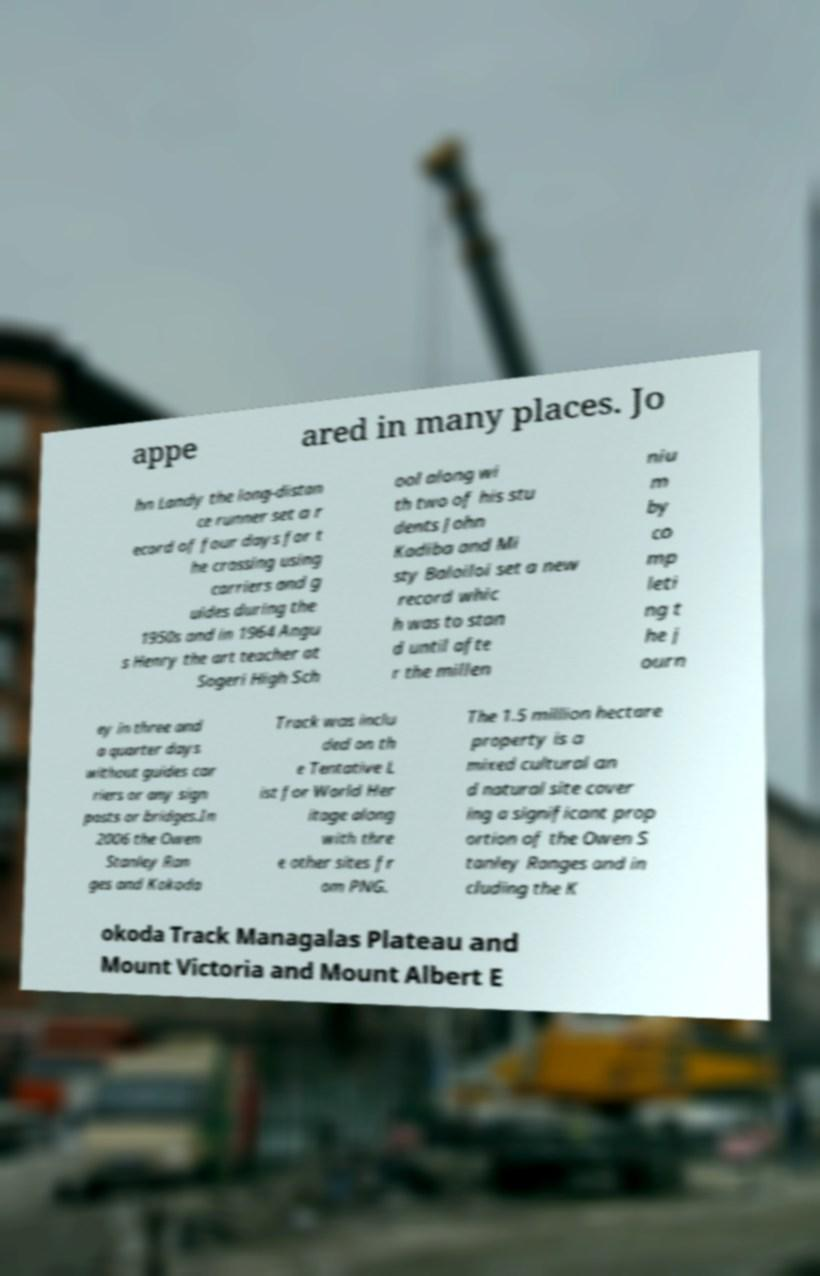Could you assist in decoding the text presented in this image and type it out clearly? appe ared in many places. Jo hn Landy the long-distan ce runner set a r ecord of four days for t he crossing using carriers and g uides during the 1950s and in 1964 Angu s Henry the art teacher at Sogeri High Sch ool along wi th two of his stu dents John Kadiba and Mi sty Baloiloi set a new record whic h was to stan d until afte r the millen niu m by co mp leti ng t he j ourn ey in three and a quarter days without guides car riers or any sign posts or bridges.In 2006 the Owen Stanley Ran ges and Kokoda Track was inclu ded on th e Tentative L ist for World Her itage along with thre e other sites fr om PNG. The 1.5 million hectare property is a mixed cultural an d natural site cover ing a significant prop ortion of the Owen S tanley Ranges and in cluding the K okoda Track Managalas Plateau and Mount Victoria and Mount Albert E 